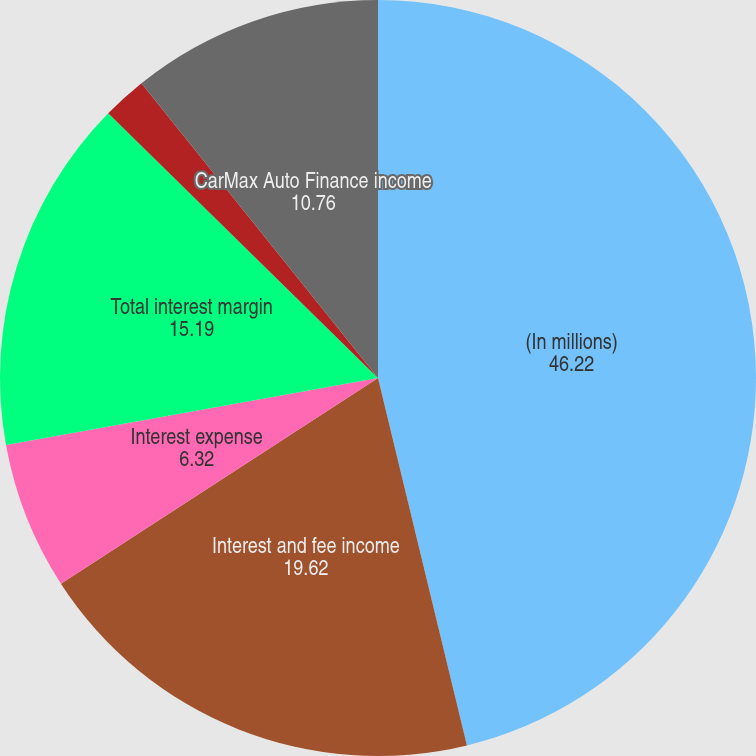<chart> <loc_0><loc_0><loc_500><loc_500><pie_chart><fcel>(In millions)<fcel>Interest and fee income<fcel>Interest expense<fcel>Total interest margin<fcel>Provision for loan losses<fcel>CarMax Auto Finance income<nl><fcel>46.22%<fcel>19.62%<fcel>6.32%<fcel>15.19%<fcel>1.89%<fcel>10.76%<nl></chart> 